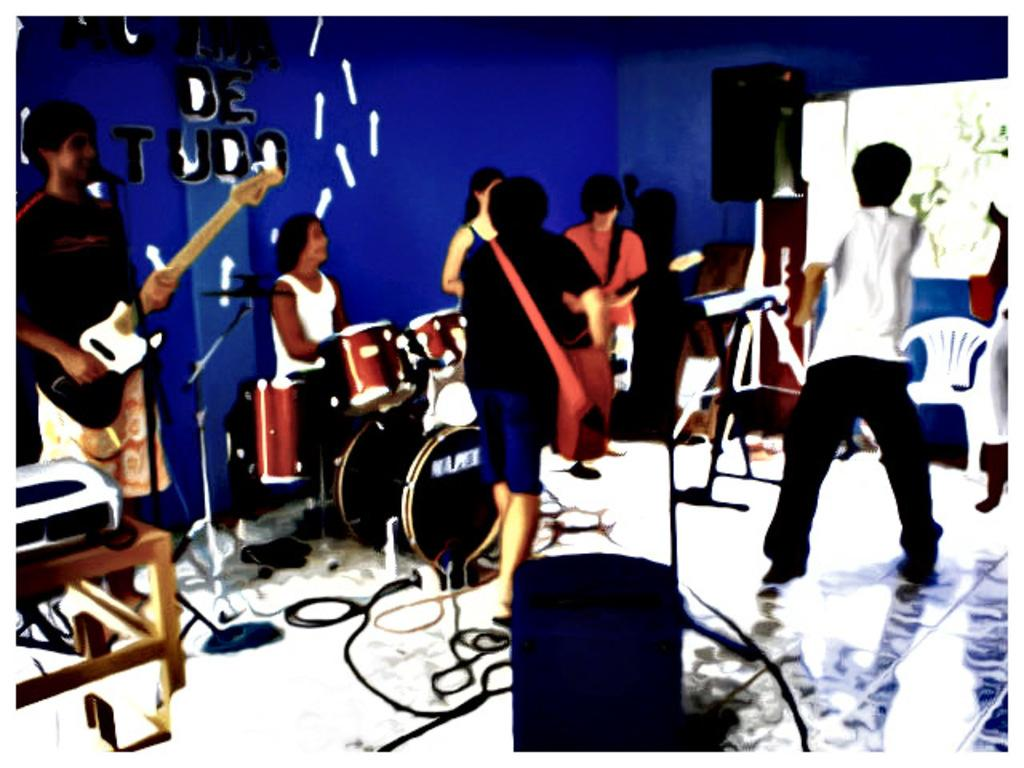Who or what can be seen in the image? There are people in the image. What objects are related to sound and visuals in the image? A: There is a sound box, a projector, and a screen in the image. What furniture is present in the image? There are chairs in the image. Can you describe the person holding an instrument in the image? There is a man holding a guitar on the left side of the image. What color is the wall visible in the image? There is a blue color wall in the image. What type of disease is being treated in the image? There is no indication of a disease or treatment in the image. What is the texture of the jelly on the floor in the image? There is no jelly present on the floor in the image. 